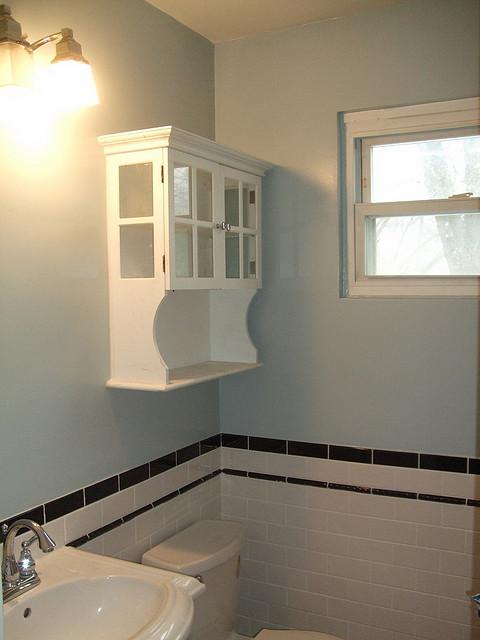Which way are the lights facing?
Write a very short answer. Down. What type of room is this?
Be succinct. Bathroom. Is the tile all white?
Keep it brief. No. Is this cabinet empty?
Keep it brief. Yes. 